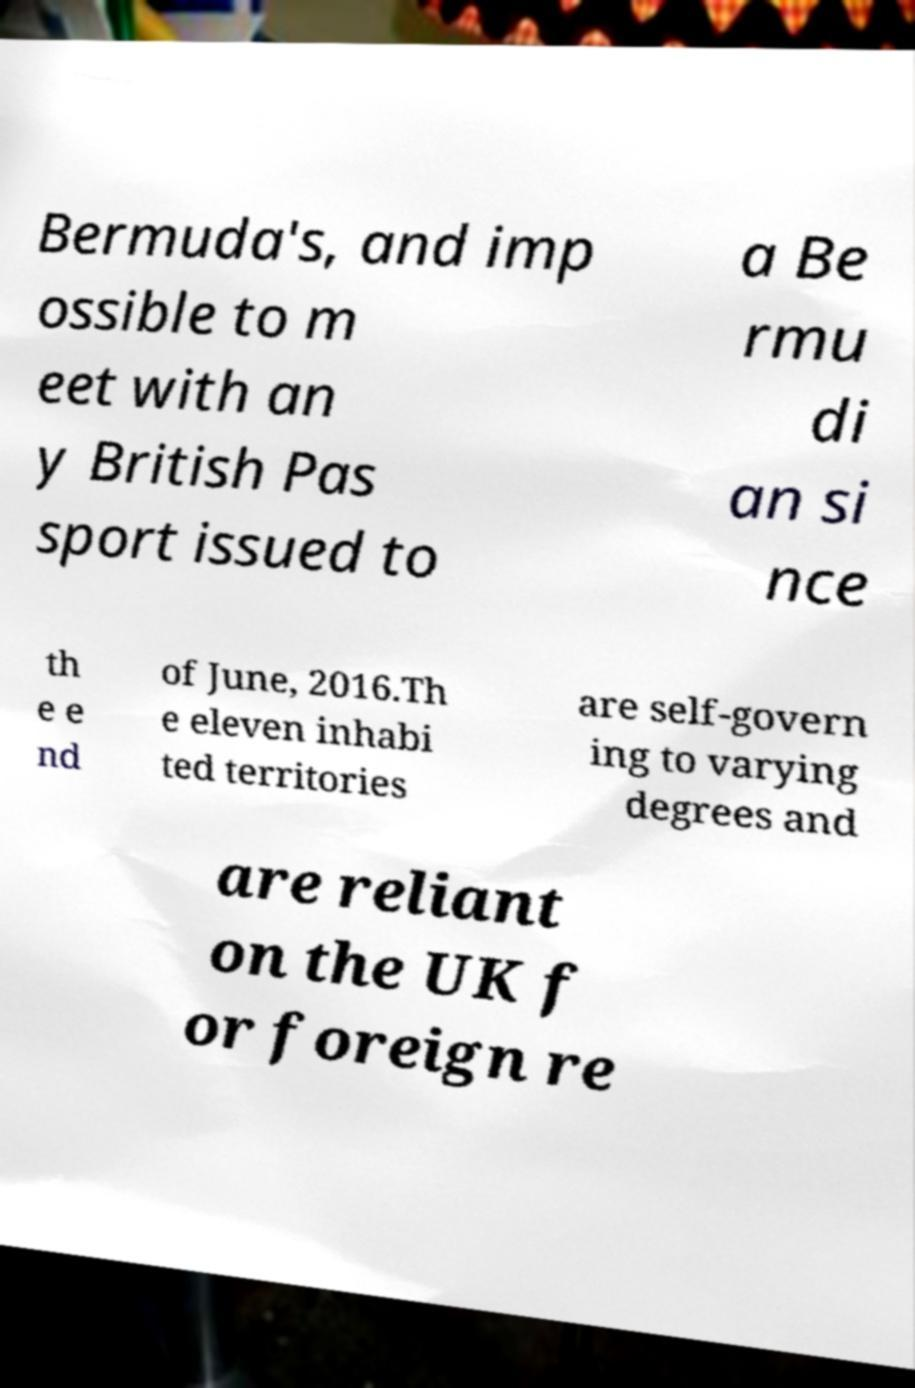Can you read and provide the text displayed in the image?This photo seems to have some interesting text. Can you extract and type it out for me? Bermuda's, and imp ossible to m eet with an y British Pas sport issued to a Be rmu di an si nce th e e nd of June, 2016.Th e eleven inhabi ted territories are self-govern ing to varying degrees and are reliant on the UK f or foreign re 